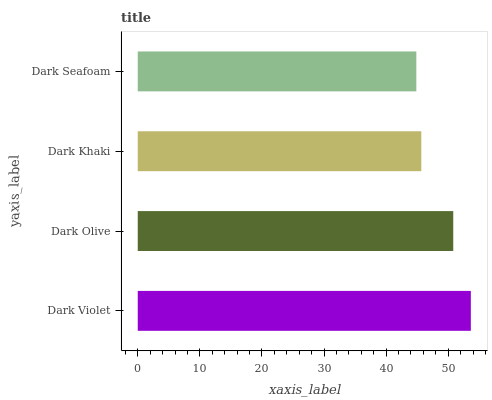Is Dark Seafoam the minimum?
Answer yes or no. Yes. Is Dark Violet the maximum?
Answer yes or no. Yes. Is Dark Olive the minimum?
Answer yes or no. No. Is Dark Olive the maximum?
Answer yes or no. No. Is Dark Violet greater than Dark Olive?
Answer yes or no. Yes. Is Dark Olive less than Dark Violet?
Answer yes or no. Yes. Is Dark Olive greater than Dark Violet?
Answer yes or no. No. Is Dark Violet less than Dark Olive?
Answer yes or no. No. Is Dark Olive the high median?
Answer yes or no. Yes. Is Dark Khaki the low median?
Answer yes or no. Yes. Is Dark Seafoam the high median?
Answer yes or no. No. Is Dark Violet the low median?
Answer yes or no. No. 